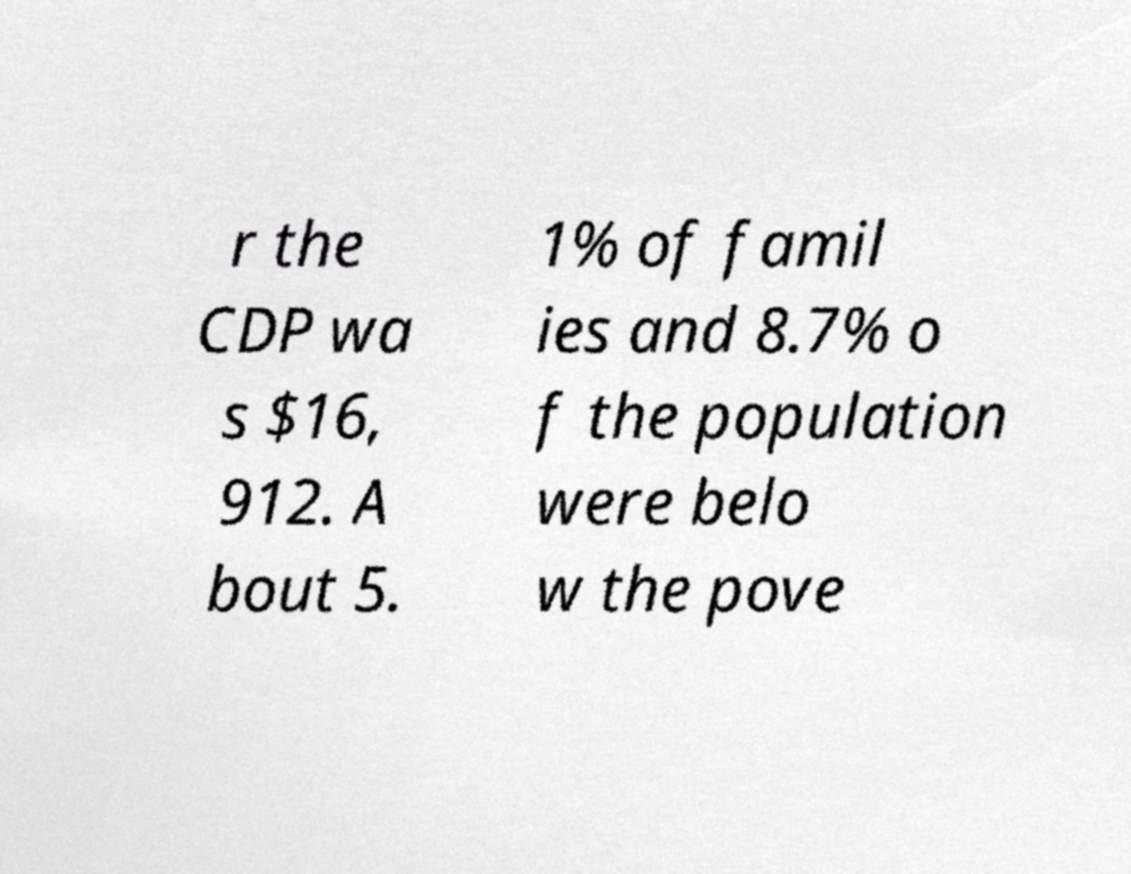Could you assist in decoding the text presented in this image and type it out clearly? r the CDP wa s $16, 912. A bout 5. 1% of famil ies and 8.7% o f the population were belo w the pove 